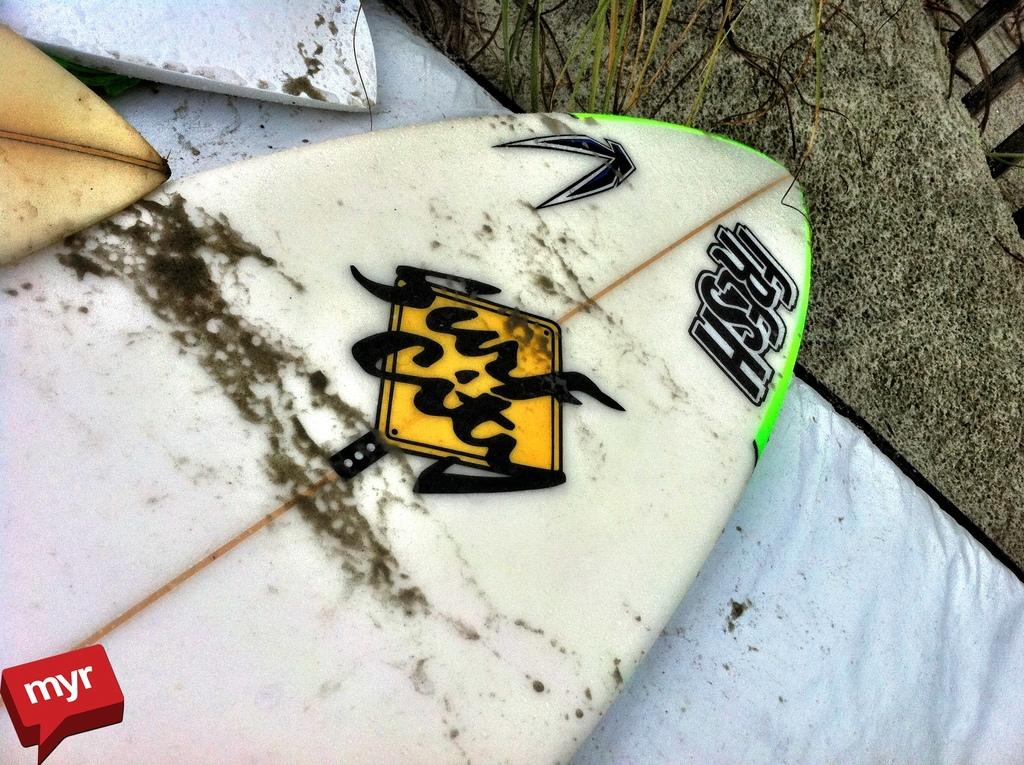What is the main subject in the center of the image? There is a surfing boat in the center of the image. Are there any other boats visible in the image? Yes, there are two other boats in the top left side of the image. What is the thought process of the nation depicted in the image? There is no nation depicted in the image, as it features boats on the water. Which direction is the north indicated in the image? There is no indication of direction, such as north, in the image. 